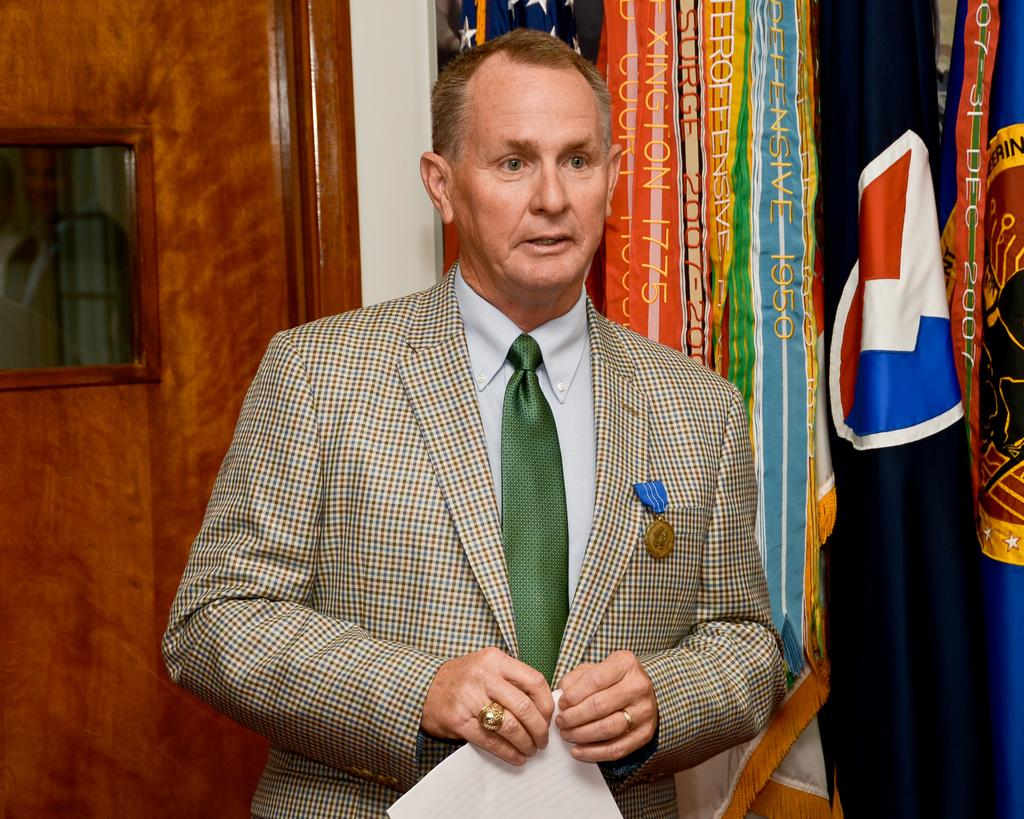What is the person in the image doing? The person is standing in the image and holding a paper. What can be seen in the background of the image? There are flags and a door in the background of the image. What type of meal is the person eating in the image? There is no meal present in the image; the person is holding a paper. What is the condition of the person's wrist in the image? There is no information about the person's wrist in the image. 